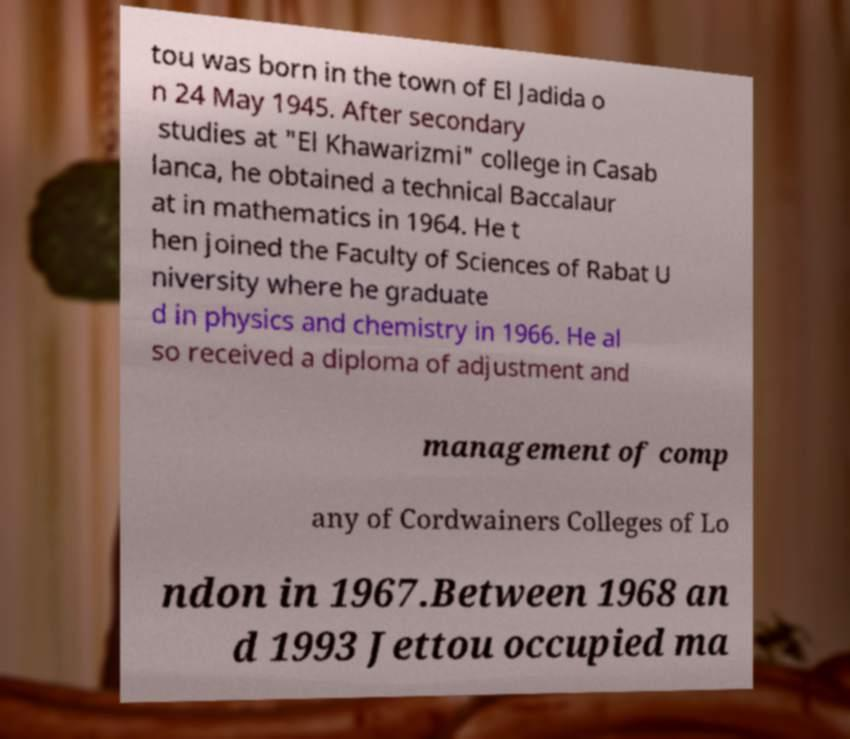Please read and relay the text visible in this image. What does it say? tou was born in the town of El Jadida o n 24 May 1945. After secondary studies at "El Khawarizmi" college in Casab lanca, he obtained a technical Baccalaur at in mathematics in 1964. He t hen joined the Faculty of Sciences of Rabat U niversity where he graduate d in physics and chemistry in 1966. He al so received a diploma of adjustment and management of comp any of Cordwainers Colleges of Lo ndon in 1967.Between 1968 an d 1993 Jettou occupied ma 